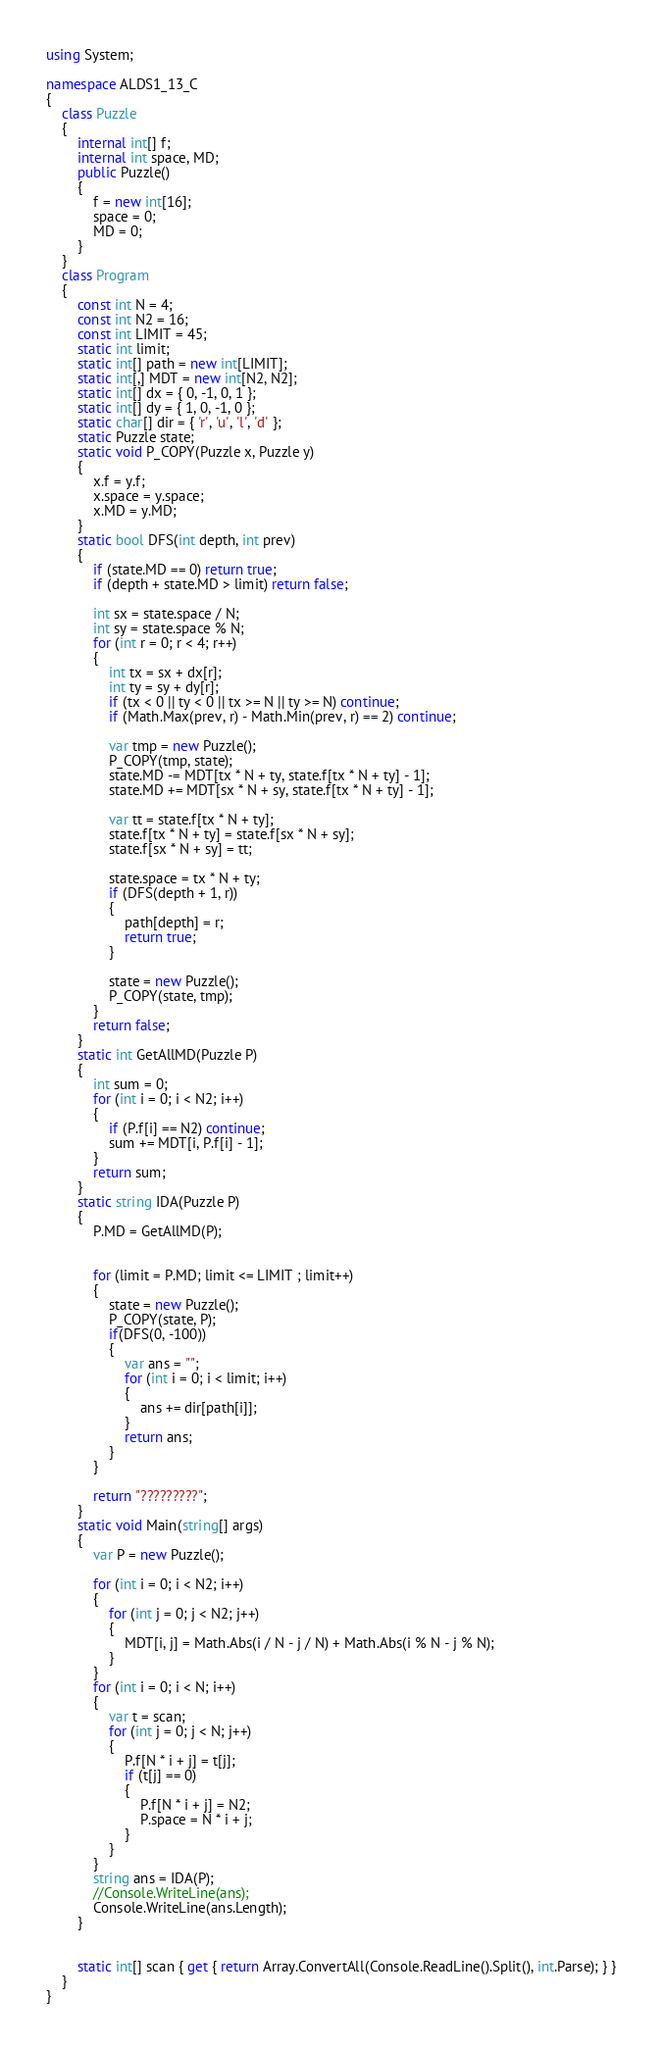<code> <loc_0><loc_0><loc_500><loc_500><_C#_>using System;

namespace ALDS1_13_C
{
    class Puzzle
    {
        internal int[] f;
        internal int space, MD;
        public Puzzle()
        {
            f = new int[16];
            space = 0;
            MD = 0;
        }
    }
    class Program
    {
        const int N = 4;
        const int N2 = 16;
        const int LIMIT = 45;
        static int limit;
        static int[] path = new int[LIMIT];
        static int[,] MDT = new int[N2, N2];
        static int[] dx = { 0, -1, 0, 1 };
        static int[] dy = { 1, 0, -1, 0 };
        static char[] dir = { 'r', 'u', 'l', 'd' };
        static Puzzle state;
        static void P_COPY(Puzzle x, Puzzle y)
        {
            x.f = y.f;
            x.space = y.space;
            x.MD = y.MD;
        }
        static bool DFS(int depth, int prev)
        {
            if (state.MD == 0) return true;
            if (depth + state.MD > limit) return false;

            int sx = state.space / N;
            int sy = state.space % N;
            for (int r = 0; r < 4; r++)
            {
                int tx = sx + dx[r];
                int ty = sy + dy[r];
                if (tx < 0 || ty < 0 || tx >= N || ty >= N) continue;
                if (Math.Max(prev, r) - Math.Min(prev, r) == 2) continue;

                var tmp = new Puzzle();
                P_COPY(tmp, state);
                state.MD -= MDT[tx * N + ty, state.f[tx * N + ty] - 1];
                state.MD += MDT[sx * N + sy, state.f[tx * N + ty] - 1];

                var tt = state.f[tx * N + ty];
                state.f[tx * N + ty] = state.f[sx * N + sy];
                state.f[sx * N + sy] = tt;

                state.space = tx * N + ty;
                if (DFS(depth + 1, r))
                {
                    path[depth] = r;
                    return true;
                }

                state = new Puzzle();
                P_COPY(state, tmp);
            }
            return false;
        }
        static int GetAllMD(Puzzle P)
        {
            int sum = 0;
            for (int i = 0; i < N2; i++)
            {
                if (P.f[i] == N2) continue;
                sum += MDT[i, P.f[i] - 1];
            }
            return sum;
        }
        static string IDA(Puzzle P)
        {
            P.MD = GetAllMD(P);


            for (limit = P.MD; limit <= LIMIT ; limit++)
            {
                state = new Puzzle();
                P_COPY(state, P);
                if(DFS(0, -100))
                {
                    var ans = "";
                    for (int i = 0; i < limit; i++)
                    {
                        ans += dir[path[i]];
                    }
                    return ans;
                }
            }

            return "?????????"; 
        }
        static void Main(string[] args)
        {
            var P = new Puzzle();

            for (int i = 0; i < N2; i++)
            {
                for (int j = 0; j < N2; j++)
                {
                    MDT[i, j] = Math.Abs(i / N - j / N) + Math.Abs(i % N - j % N);
                }
            }       
            for (int i = 0; i < N; i++)
            {
                var t = scan;
                for (int j = 0; j < N; j++)
                {
                    P.f[N * i + j] = t[j];
                    if (t[j] == 0)
                    {
                        P.f[N * i + j] = N2;
                        P.space = N * i + j;
                    }
                }
            }
            string ans = IDA(P);
            //Console.WriteLine(ans);
            Console.WriteLine(ans.Length);
        }
      

        static int[] scan { get { return Array.ConvertAll(Console.ReadLine().Split(), int.Parse); } }
    }
}</code> 